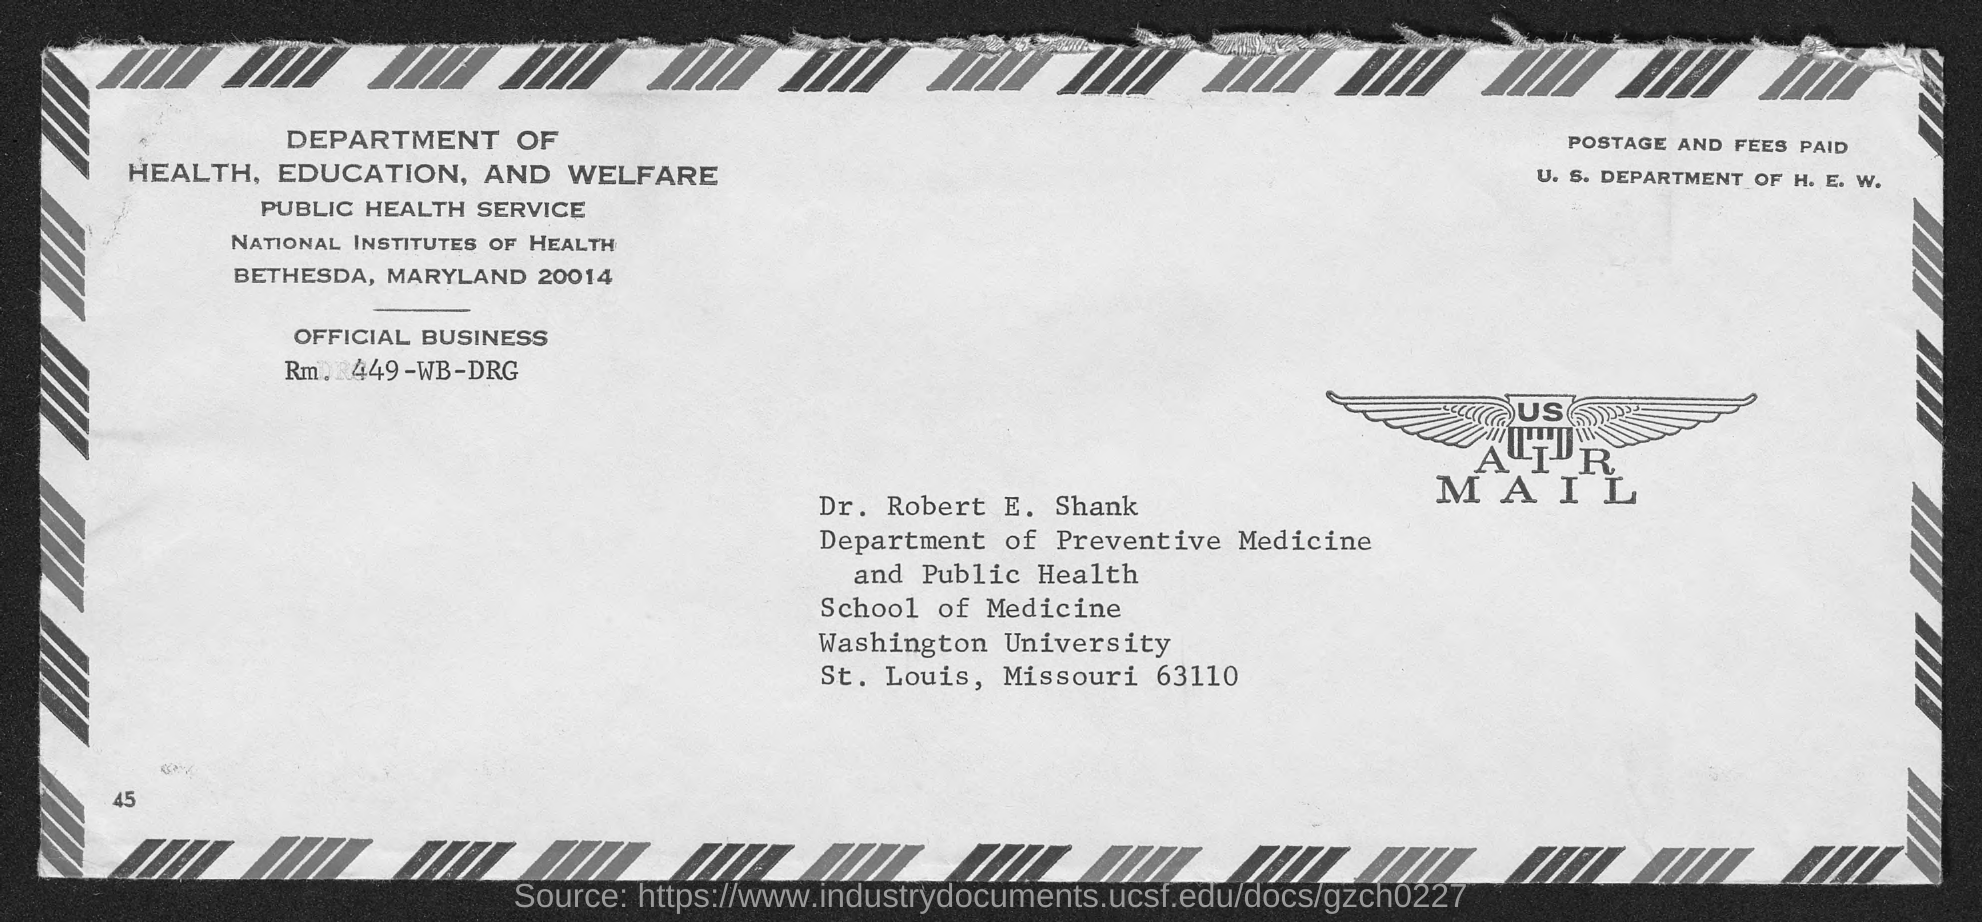To which department does Dr.Robert E. Shank belong to?
Make the answer very short. Department of Preventive Medicine and Public Health. Which state does dr. robert e. shank belong to?
Keep it short and to the point. Missouri. 